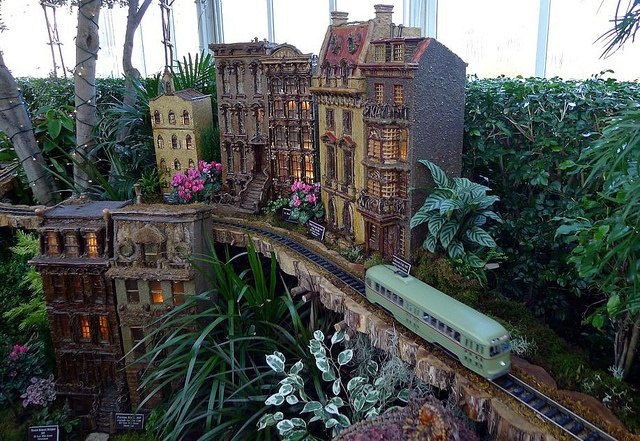Describe the objects in this image and their specific colors. I can see a train in purple, darkgray, and gray tones in this image. 